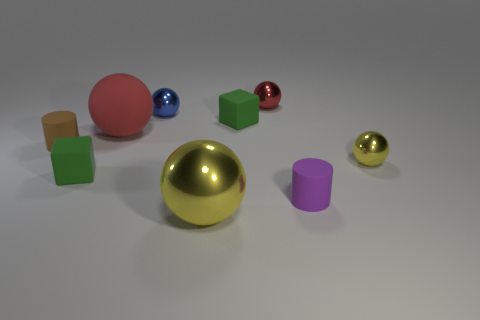Which objects in the image appear to be made of metal? Based on their reflective surfaces and sheen, two objects in the image appear to be made of metal—a large gold sphere and a small gold sphere. 